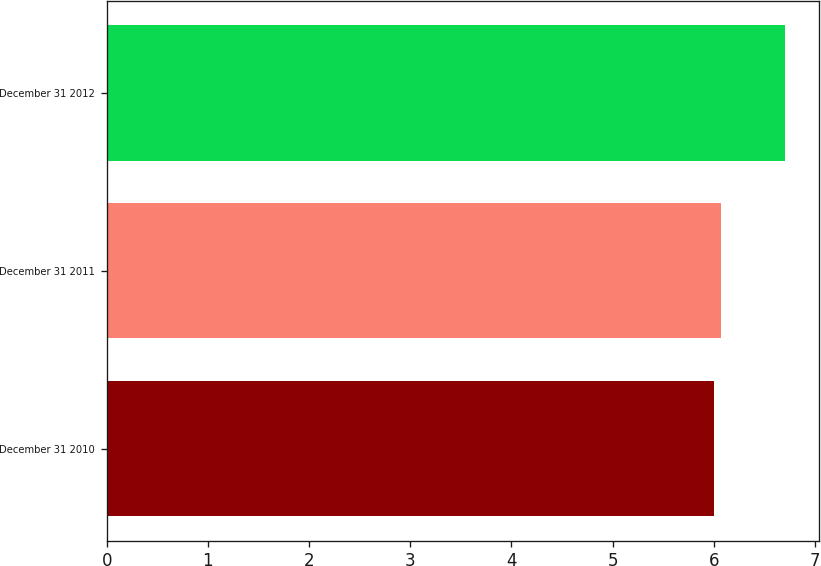Convert chart. <chart><loc_0><loc_0><loc_500><loc_500><bar_chart><fcel>December 31 2010<fcel>December 31 2011<fcel>December 31 2012<nl><fcel>6<fcel>6.07<fcel>6.7<nl></chart> 